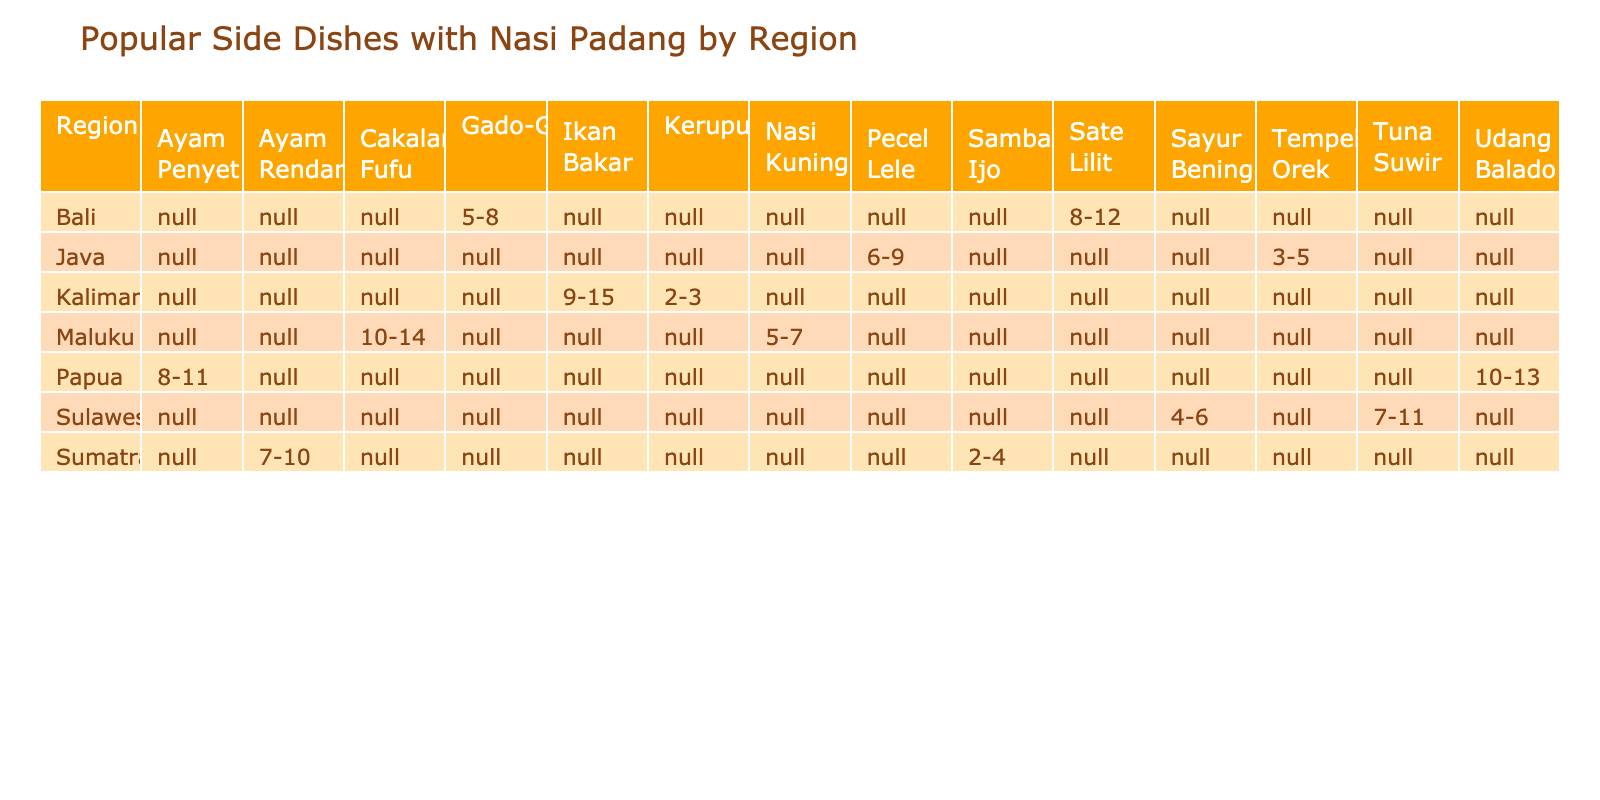What is the price range for Ayam Rendang in Sumatra? The table shows that the price range for Ayam Rendang listed under the Sumatra region is 7-10.
Answer: 7-10 Which region offers Gado-Gado? By looking at the table, Gado-Gado is listed under the Bali region.
Answer: Bali How many side dishes from Kalimantan are priced between 2-5? In the Kalimantan region, there's one dish, Kerupuk, priced at 2-3, while Ikan Bakar is priced at 9-15. The only dish that fits the price range 2-5 is Kerupuk, so the count is 1.
Answer: 1 What is the total number of side dishes listed for the Sulawesi region? The table shows two side dishes from Sulawesi: Tuna Suwir and Sayur Bening, thus totaling to 2.
Answer: 2 Is there any side dish from Maluku that costs between 5-10? In Maluku, the side dishes are Nasi Kuning priced at 5-7 and Cakalang Fufu priced at 10-14. Since Nasi Kuning is between 5-10, the answer is yes.
Answer: Yes Which side dishes from Java are cheaper than those from Bali? The side dishes from Java include Tempeh Orek (3-5) and Pecel Lele (6-9). In Bali, Sate Lilit (8-12) and Gado-Gado (5-8) are present. Comparing prices, both Tempeh Orek and Gado-Gado fit the criteria, but only Tempeh Orek under 5 is cheaper than Sate Lilit, while Pecel Lele is not cheaper than Gado-Gado. Therefore, the answer is Tempeh Orek.
Answer: Tempeh Orek What is the average price range for side dishes in Papua? The side dishes from Papua are Ayam Penyet (8-11) and Udang Balado (10-13). The average of the minimum prices (8 + 10) / 2 = 9, and for maximum prices (11 + 13) / 2 = 12. The average range for side dishes in Papua is 9-12.
Answer: 9-12 Identify the only side dish from Kalimantan that has a price below 4. The only side dish that falls under this price point is Kerupuk, priced at 2-3, while Ikan Bakar is above that range.
Answer: Kerupuk Which regions have a side dish priced between 10-14 USD? Within the table, the regions with side dishes priced between 10-14 are Kalimantan with Ikan Bakar and Maluku with Cakalang Fufu. Therefore, two regions meet this criterion.
Answer: Kalimantan, Maluku 